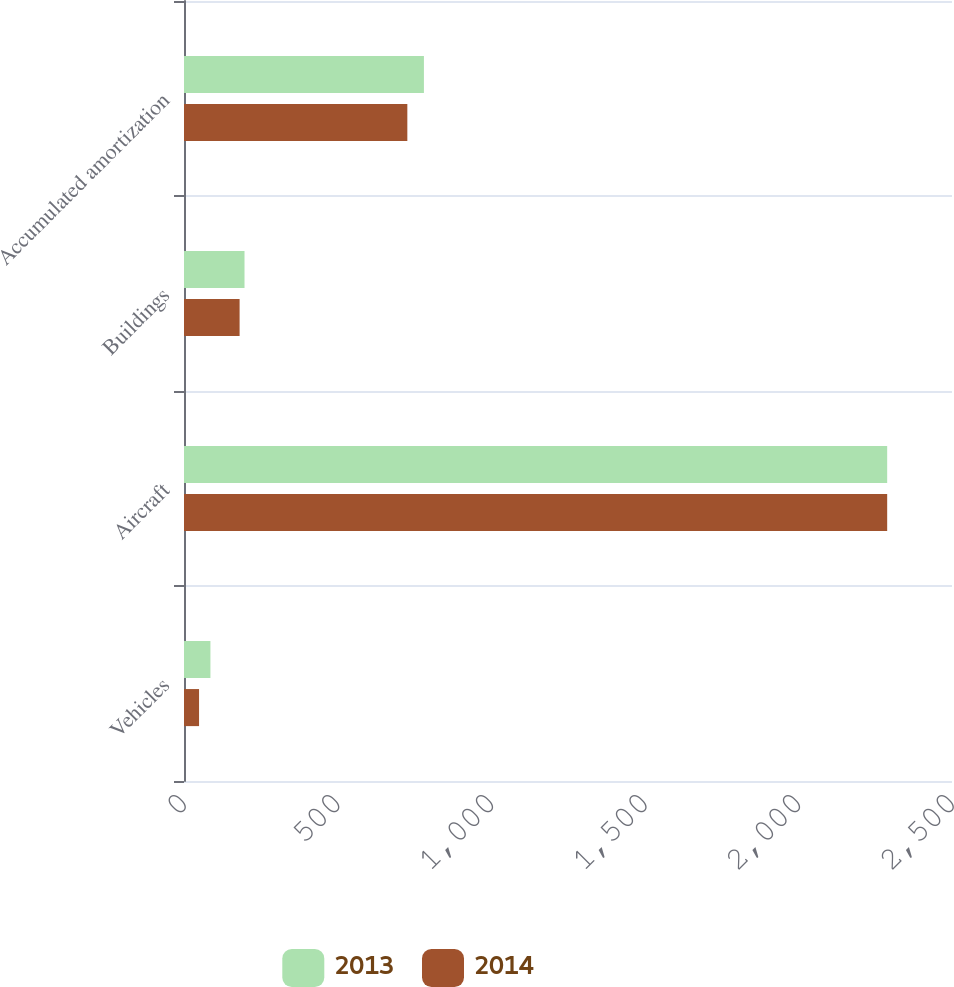<chart> <loc_0><loc_0><loc_500><loc_500><stacked_bar_chart><ecel><fcel>Vehicles<fcel>Aircraft<fcel>Buildings<fcel>Accumulated amortization<nl><fcel>2013<fcel>86<fcel>2289<fcel>197<fcel>781<nl><fcel>2014<fcel>49<fcel>2289<fcel>181<fcel>727<nl></chart> 